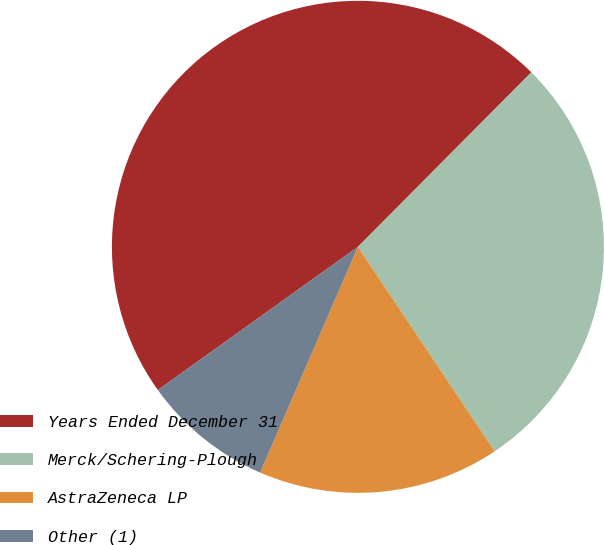Convert chart to OTSL. <chart><loc_0><loc_0><loc_500><loc_500><pie_chart><fcel>Years Ended December 31<fcel>Merck/Schering-Plough<fcel>AstraZeneca LP<fcel>Other (1)<nl><fcel>47.34%<fcel>28.17%<fcel>15.89%<fcel>8.61%<nl></chart> 